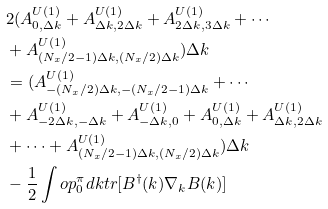Convert formula to latex. <formula><loc_0><loc_0><loc_500><loc_500>& 2 ( A _ { 0 , \Delta k } ^ { U ( 1 ) } + A _ { \Delta k , 2 \Delta k } ^ { U ( 1 ) } + A _ { 2 \Delta k , 3 \Delta k } ^ { U ( 1 ) } + \cdots \\ & + A _ { ( N _ { x } / 2 - 1 ) \Delta k , ( N _ { x } / 2 ) \Delta k } ^ { U ( 1 ) } ) \Delta k \\ & = ( A _ { - ( N _ { x } / 2 ) \Delta k , - ( N _ { x } / 2 - 1 ) \Delta k } ^ { U ( 1 ) } + \cdots \\ & + A _ { - 2 \Delta k , - \Delta k } ^ { U ( 1 ) } + A _ { - \Delta k , 0 } ^ { U ( 1 ) } + A _ { 0 , \Delta k } ^ { U ( 1 ) } + A _ { \Delta k , 2 \Delta k } ^ { U ( 1 ) } \\ & + \cdots + A _ { ( N _ { x } / 2 - 1 ) \Delta k , ( N _ { x } / 2 ) \Delta k } ^ { U ( 1 ) } ) \Delta k \\ & - \frac { 1 } { 2 } \int o p _ { 0 } ^ { \pi } d k t r [ B ^ { \dagger } ( k ) \nabla _ { k } B ( k ) ]</formula> 